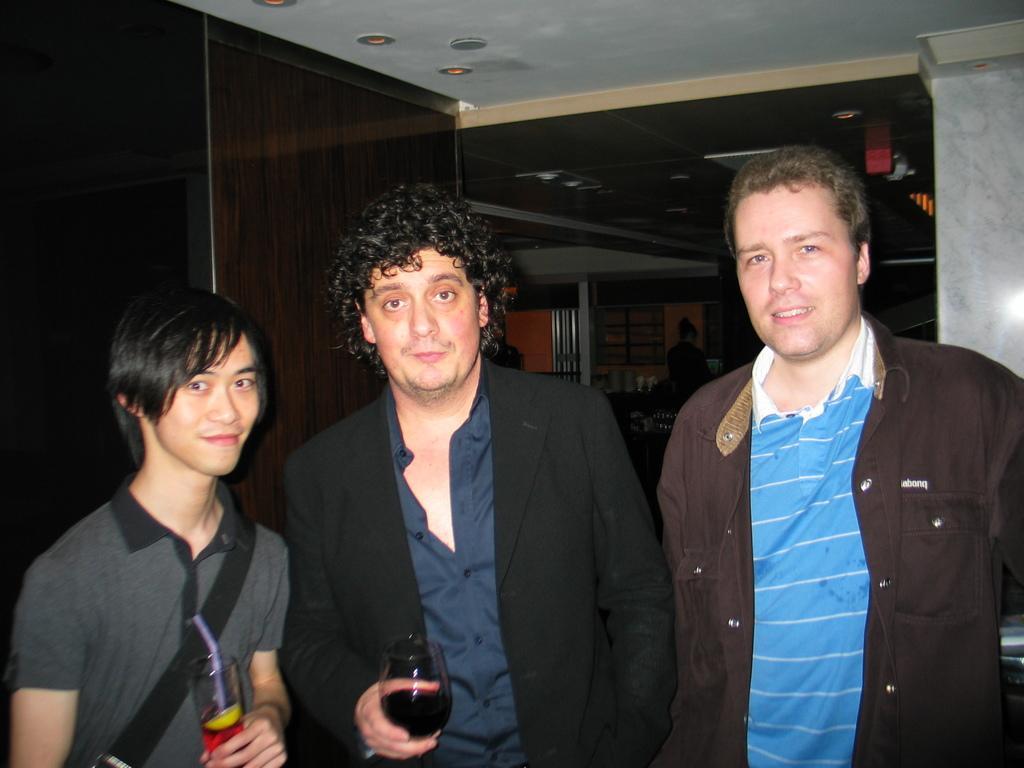In one or two sentences, can you explain what this image depicts? In this image, we can see three people are smiling and seeing. Here two persons are holding glasses with liquid. Background we can see pillar, wall, some objects, lights. 